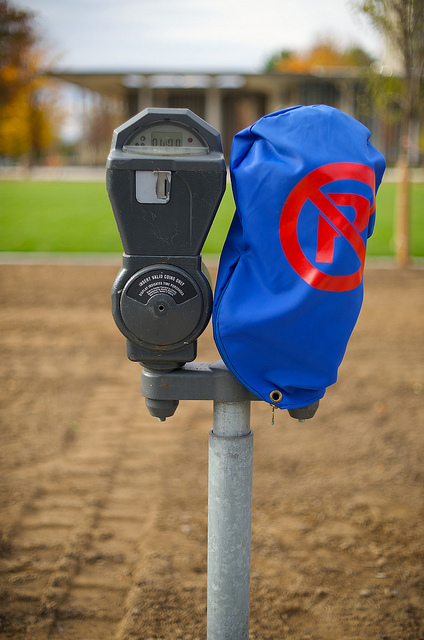<image>What picture is on the parking meter? I don't know what picture is on the parking meter, maybe it is a 'no parking' sign or symbol. What picture is on the parking meter? The picture on the parking meter is unclear. However, it can be seen a "no parking" sign. 